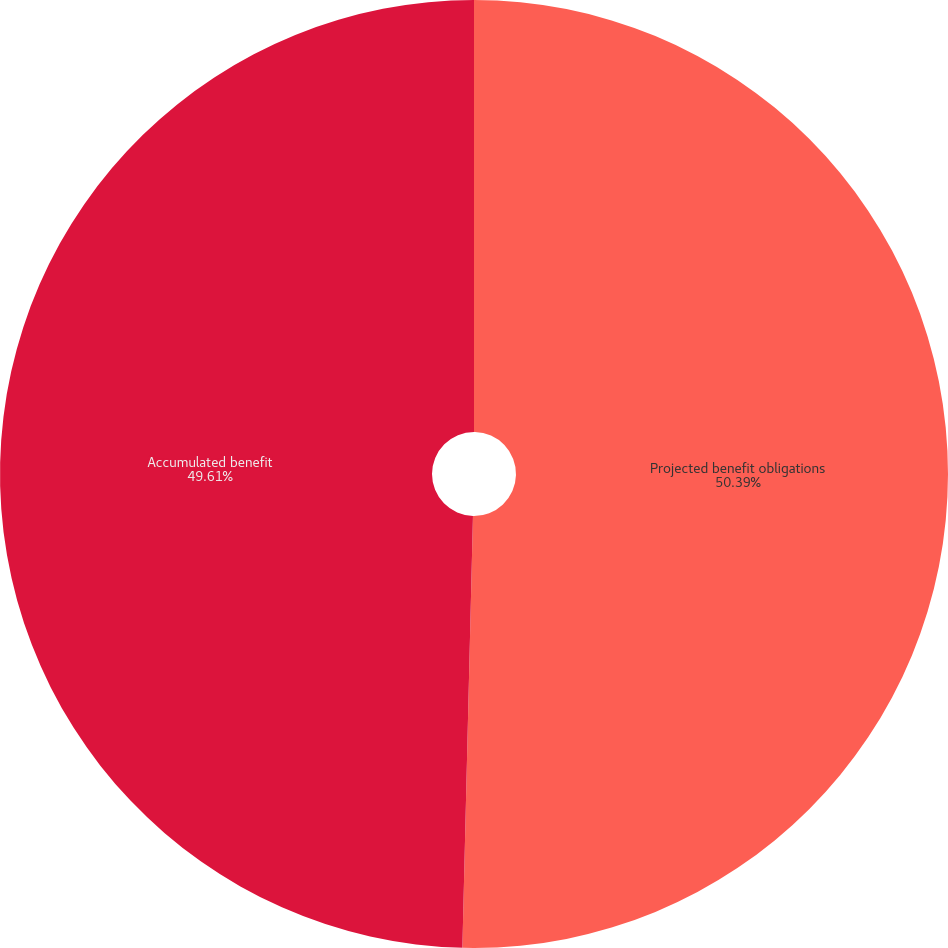Convert chart to OTSL. <chart><loc_0><loc_0><loc_500><loc_500><pie_chart><fcel>Projected benefit obligations<fcel>Accumulated benefit<nl><fcel>50.39%<fcel>49.61%<nl></chart> 